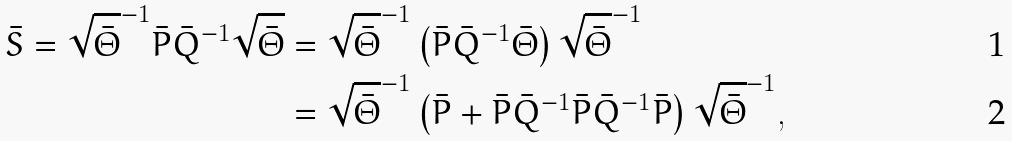Convert formula to latex. <formula><loc_0><loc_0><loc_500><loc_500>\bar { S } = \sqrt { \bar { \Theta } } ^ { - 1 } \bar { P } \bar { Q } ^ { - 1 } \sqrt { \bar { \Theta } } & = \sqrt { \bar { \Theta } } ^ { - 1 } \left ( \bar { P } \bar { Q } ^ { - 1 } \bar { \Theta } \right ) \sqrt { \bar { \Theta } } ^ { - 1 } \\ & = \sqrt { \bar { \Theta } } ^ { - 1 } \left ( \bar { P } + \bar { P } \bar { Q } ^ { - 1 } \bar { P } \bar { Q } ^ { - 1 } \bar { P } \right ) \sqrt { \bar { \Theta } } ^ { - 1 } ,</formula> 